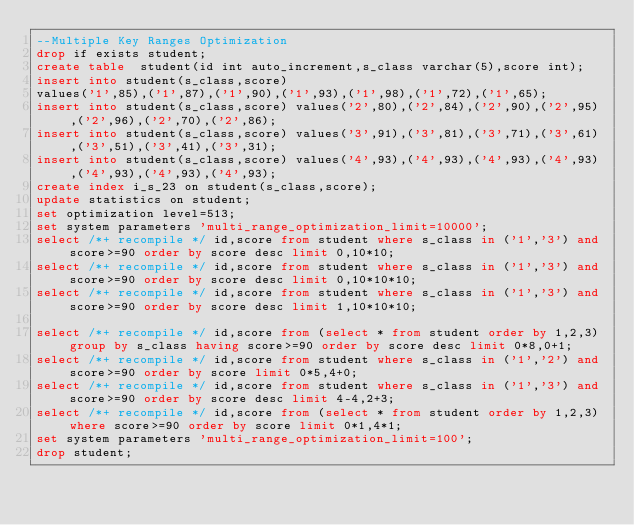Convert code to text. <code><loc_0><loc_0><loc_500><loc_500><_SQL_>--Multiple Key Ranges Optimization
drop if exists student;
create table  student(id int auto_increment,s_class varchar(5),score int);
insert into student(s_class,score)
values('1',85),('1',87),('1',90),('1',93),('1',98),('1',72),('1',65);
insert into student(s_class,score) values('2',80),('2',84),('2',90),('2',95),('2',96),('2',70),('2',86);
insert into student(s_class,score) values('3',91),('3',81),('3',71),('3',61),('3',51),('3',41),('3',31);
insert into student(s_class,score) values('4',93),('4',93),('4',93),('4',93),('4',93),('4',93),('4',93);
create index i_s_23 on student(s_class,score);
update statistics on student;
set optimization level=513;
set system parameters 'multi_range_optimization_limit=10000';
select /*+ recompile */ id,score from student where s_class in ('1','3') and score>=90 order by score desc limit 0,10*10; 
select /*+ recompile */ id,score from student where s_class in ('1','3') and score>=90 order by score desc limit 0,10*10*10;
select /*+ recompile */ id,score from student where s_class in ('1','3') and score>=90 order by score desc limit 1,10*10*10;

select /*+ recompile */ id,score from (select * from student order by 1,2,3) group by s_class having score>=90 order by score desc limit 0*8,0+1;
select /*+ recompile */ id,score from student where s_class in ('1','2') and score>=90 order by score limit 0*5,4+0;
select /*+ recompile */ id,score from student where s_class in ('1','3') and score>=90 order by score desc limit 4-4,2+3;
select /*+ recompile */ id,score from (select * from student order by 1,2,3) where score>=90 order by score limit 0*1,4*1;
set system parameters 'multi_range_optimization_limit=100';
drop student;
</code> 